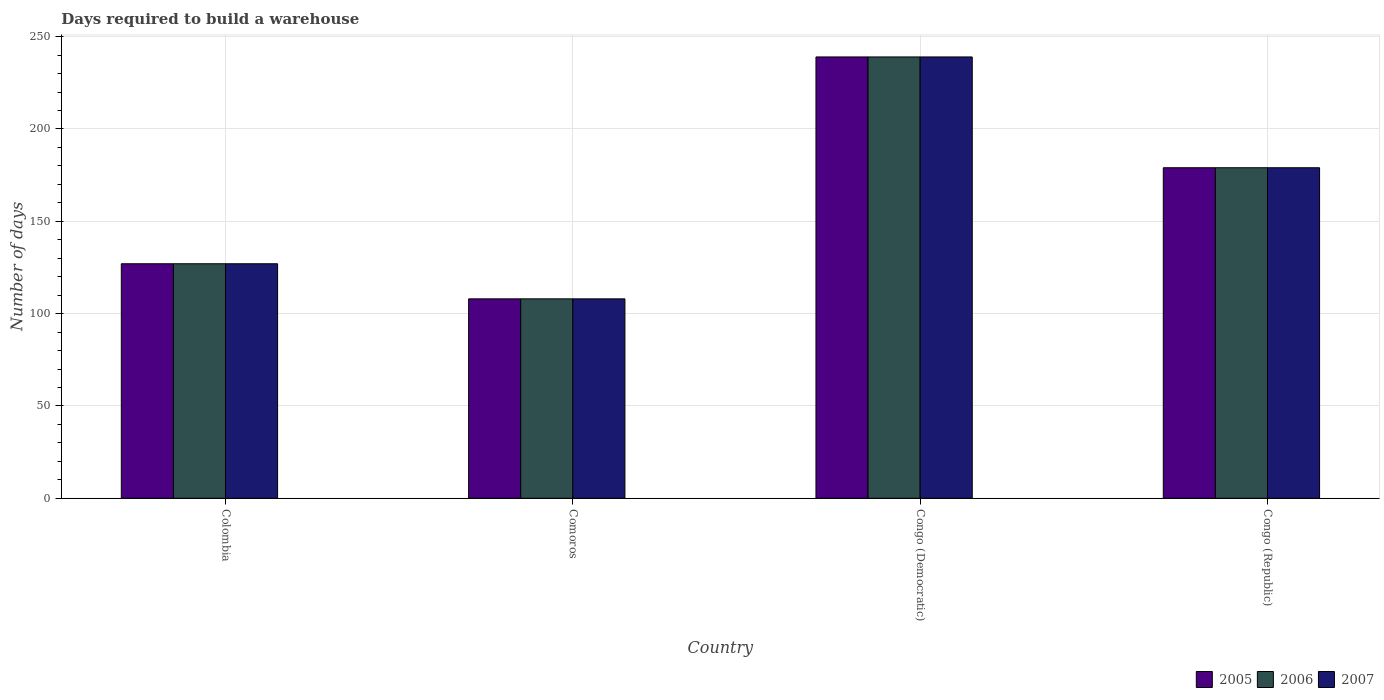Are the number of bars per tick equal to the number of legend labels?
Your answer should be very brief. Yes. How many bars are there on the 4th tick from the right?
Your response must be concise. 3. What is the label of the 4th group of bars from the left?
Keep it short and to the point. Congo (Republic). What is the days required to build a warehouse in in 2005 in Congo (Democratic)?
Offer a very short reply. 239. Across all countries, what is the maximum days required to build a warehouse in in 2007?
Keep it short and to the point. 239. Across all countries, what is the minimum days required to build a warehouse in in 2005?
Your answer should be very brief. 108. In which country was the days required to build a warehouse in in 2005 maximum?
Provide a succinct answer. Congo (Democratic). In which country was the days required to build a warehouse in in 2005 minimum?
Make the answer very short. Comoros. What is the total days required to build a warehouse in in 2007 in the graph?
Offer a very short reply. 653. What is the difference between the days required to build a warehouse in in 2005 in Colombia and that in Congo (Republic)?
Give a very brief answer. -52. What is the difference between the days required to build a warehouse in in 2006 in Comoros and the days required to build a warehouse in in 2007 in Colombia?
Your answer should be compact. -19. What is the average days required to build a warehouse in in 2007 per country?
Provide a succinct answer. 163.25. What is the ratio of the days required to build a warehouse in in 2007 in Congo (Democratic) to that in Congo (Republic)?
Keep it short and to the point. 1.34. Is the days required to build a warehouse in in 2005 in Comoros less than that in Congo (Republic)?
Make the answer very short. Yes. Is the difference between the days required to build a warehouse in in 2007 in Congo (Democratic) and Congo (Republic) greater than the difference between the days required to build a warehouse in in 2006 in Congo (Democratic) and Congo (Republic)?
Offer a terse response. No. What is the difference between the highest and the second highest days required to build a warehouse in in 2007?
Offer a terse response. 52. What is the difference between the highest and the lowest days required to build a warehouse in in 2006?
Offer a very short reply. 131. What does the 3rd bar from the right in Colombia represents?
Your response must be concise. 2005. Is it the case that in every country, the sum of the days required to build a warehouse in in 2005 and days required to build a warehouse in in 2007 is greater than the days required to build a warehouse in in 2006?
Your answer should be very brief. Yes. How many bars are there?
Offer a very short reply. 12. How many countries are there in the graph?
Keep it short and to the point. 4. How many legend labels are there?
Your answer should be very brief. 3. How are the legend labels stacked?
Keep it short and to the point. Horizontal. What is the title of the graph?
Offer a terse response. Days required to build a warehouse. What is the label or title of the Y-axis?
Your answer should be compact. Number of days. What is the Number of days of 2005 in Colombia?
Provide a short and direct response. 127. What is the Number of days of 2006 in Colombia?
Ensure brevity in your answer.  127. What is the Number of days in 2007 in Colombia?
Your response must be concise. 127. What is the Number of days of 2005 in Comoros?
Offer a very short reply. 108. What is the Number of days of 2006 in Comoros?
Ensure brevity in your answer.  108. What is the Number of days in 2007 in Comoros?
Keep it short and to the point. 108. What is the Number of days of 2005 in Congo (Democratic)?
Offer a very short reply. 239. What is the Number of days in 2006 in Congo (Democratic)?
Make the answer very short. 239. What is the Number of days of 2007 in Congo (Democratic)?
Your answer should be very brief. 239. What is the Number of days of 2005 in Congo (Republic)?
Give a very brief answer. 179. What is the Number of days in 2006 in Congo (Republic)?
Offer a very short reply. 179. What is the Number of days of 2007 in Congo (Republic)?
Your answer should be compact. 179. Across all countries, what is the maximum Number of days in 2005?
Offer a very short reply. 239. Across all countries, what is the maximum Number of days in 2006?
Your answer should be compact. 239. Across all countries, what is the maximum Number of days of 2007?
Your response must be concise. 239. Across all countries, what is the minimum Number of days in 2005?
Offer a terse response. 108. Across all countries, what is the minimum Number of days in 2006?
Your response must be concise. 108. Across all countries, what is the minimum Number of days of 2007?
Your response must be concise. 108. What is the total Number of days of 2005 in the graph?
Offer a very short reply. 653. What is the total Number of days in 2006 in the graph?
Offer a very short reply. 653. What is the total Number of days of 2007 in the graph?
Keep it short and to the point. 653. What is the difference between the Number of days of 2005 in Colombia and that in Comoros?
Make the answer very short. 19. What is the difference between the Number of days in 2005 in Colombia and that in Congo (Democratic)?
Make the answer very short. -112. What is the difference between the Number of days in 2006 in Colombia and that in Congo (Democratic)?
Your answer should be compact. -112. What is the difference between the Number of days in 2007 in Colombia and that in Congo (Democratic)?
Offer a terse response. -112. What is the difference between the Number of days of 2005 in Colombia and that in Congo (Republic)?
Your response must be concise. -52. What is the difference between the Number of days of 2006 in Colombia and that in Congo (Republic)?
Provide a short and direct response. -52. What is the difference between the Number of days in 2007 in Colombia and that in Congo (Republic)?
Provide a short and direct response. -52. What is the difference between the Number of days of 2005 in Comoros and that in Congo (Democratic)?
Keep it short and to the point. -131. What is the difference between the Number of days of 2006 in Comoros and that in Congo (Democratic)?
Offer a very short reply. -131. What is the difference between the Number of days of 2007 in Comoros and that in Congo (Democratic)?
Give a very brief answer. -131. What is the difference between the Number of days in 2005 in Comoros and that in Congo (Republic)?
Your response must be concise. -71. What is the difference between the Number of days of 2006 in Comoros and that in Congo (Republic)?
Provide a short and direct response. -71. What is the difference between the Number of days in 2007 in Comoros and that in Congo (Republic)?
Offer a terse response. -71. What is the difference between the Number of days in 2005 in Congo (Democratic) and that in Congo (Republic)?
Provide a short and direct response. 60. What is the difference between the Number of days of 2006 in Congo (Democratic) and that in Congo (Republic)?
Your response must be concise. 60. What is the difference between the Number of days in 2007 in Congo (Democratic) and that in Congo (Republic)?
Your answer should be very brief. 60. What is the difference between the Number of days of 2005 in Colombia and the Number of days of 2006 in Comoros?
Keep it short and to the point. 19. What is the difference between the Number of days of 2006 in Colombia and the Number of days of 2007 in Comoros?
Provide a succinct answer. 19. What is the difference between the Number of days of 2005 in Colombia and the Number of days of 2006 in Congo (Democratic)?
Ensure brevity in your answer.  -112. What is the difference between the Number of days in 2005 in Colombia and the Number of days in 2007 in Congo (Democratic)?
Offer a very short reply. -112. What is the difference between the Number of days in 2006 in Colombia and the Number of days in 2007 in Congo (Democratic)?
Offer a terse response. -112. What is the difference between the Number of days of 2005 in Colombia and the Number of days of 2006 in Congo (Republic)?
Provide a succinct answer. -52. What is the difference between the Number of days of 2005 in Colombia and the Number of days of 2007 in Congo (Republic)?
Your response must be concise. -52. What is the difference between the Number of days of 2006 in Colombia and the Number of days of 2007 in Congo (Republic)?
Provide a short and direct response. -52. What is the difference between the Number of days in 2005 in Comoros and the Number of days in 2006 in Congo (Democratic)?
Your response must be concise. -131. What is the difference between the Number of days of 2005 in Comoros and the Number of days of 2007 in Congo (Democratic)?
Your answer should be very brief. -131. What is the difference between the Number of days in 2006 in Comoros and the Number of days in 2007 in Congo (Democratic)?
Your response must be concise. -131. What is the difference between the Number of days in 2005 in Comoros and the Number of days in 2006 in Congo (Republic)?
Keep it short and to the point. -71. What is the difference between the Number of days of 2005 in Comoros and the Number of days of 2007 in Congo (Republic)?
Your answer should be very brief. -71. What is the difference between the Number of days of 2006 in Comoros and the Number of days of 2007 in Congo (Republic)?
Give a very brief answer. -71. What is the difference between the Number of days of 2005 in Congo (Democratic) and the Number of days of 2007 in Congo (Republic)?
Make the answer very short. 60. What is the average Number of days of 2005 per country?
Offer a very short reply. 163.25. What is the average Number of days of 2006 per country?
Provide a succinct answer. 163.25. What is the average Number of days of 2007 per country?
Your answer should be very brief. 163.25. What is the difference between the Number of days of 2005 and Number of days of 2007 in Colombia?
Your response must be concise. 0. What is the difference between the Number of days of 2006 and Number of days of 2007 in Colombia?
Offer a very short reply. 0. What is the difference between the Number of days in 2005 and Number of days in 2006 in Congo (Democratic)?
Your response must be concise. 0. What is the difference between the Number of days of 2005 and Number of days of 2007 in Congo (Democratic)?
Offer a very short reply. 0. What is the difference between the Number of days in 2005 and Number of days in 2006 in Congo (Republic)?
Make the answer very short. 0. What is the difference between the Number of days in 2005 and Number of days in 2007 in Congo (Republic)?
Provide a short and direct response. 0. What is the difference between the Number of days of 2006 and Number of days of 2007 in Congo (Republic)?
Ensure brevity in your answer.  0. What is the ratio of the Number of days of 2005 in Colombia to that in Comoros?
Give a very brief answer. 1.18. What is the ratio of the Number of days in 2006 in Colombia to that in Comoros?
Offer a terse response. 1.18. What is the ratio of the Number of days in 2007 in Colombia to that in Comoros?
Your answer should be very brief. 1.18. What is the ratio of the Number of days in 2005 in Colombia to that in Congo (Democratic)?
Your answer should be very brief. 0.53. What is the ratio of the Number of days of 2006 in Colombia to that in Congo (Democratic)?
Offer a very short reply. 0.53. What is the ratio of the Number of days of 2007 in Colombia to that in Congo (Democratic)?
Provide a succinct answer. 0.53. What is the ratio of the Number of days of 2005 in Colombia to that in Congo (Republic)?
Provide a short and direct response. 0.71. What is the ratio of the Number of days of 2006 in Colombia to that in Congo (Republic)?
Keep it short and to the point. 0.71. What is the ratio of the Number of days of 2007 in Colombia to that in Congo (Republic)?
Provide a short and direct response. 0.71. What is the ratio of the Number of days in 2005 in Comoros to that in Congo (Democratic)?
Ensure brevity in your answer.  0.45. What is the ratio of the Number of days of 2006 in Comoros to that in Congo (Democratic)?
Make the answer very short. 0.45. What is the ratio of the Number of days in 2007 in Comoros to that in Congo (Democratic)?
Keep it short and to the point. 0.45. What is the ratio of the Number of days in 2005 in Comoros to that in Congo (Republic)?
Your answer should be compact. 0.6. What is the ratio of the Number of days of 2006 in Comoros to that in Congo (Republic)?
Keep it short and to the point. 0.6. What is the ratio of the Number of days of 2007 in Comoros to that in Congo (Republic)?
Offer a very short reply. 0.6. What is the ratio of the Number of days of 2005 in Congo (Democratic) to that in Congo (Republic)?
Ensure brevity in your answer.  1.34. What is the ratio of the Number of days in 2006 in Congo (Democratic) to that in Congo (Republic)?
Offer a very short reply. 1.34. What is the ratio of the Number of days in 2007 in Congo (Democratic) to that in Congo (Republic)?
Your answer should be very brief. 1.34. What is the difference between the highest and the second highest Number of days of 2006?
Offer a terse response. 60. What is the difference between the highest and the second highest Number of days of 2007?
Your response must be concise. 60. What is the difference between the highest and the lowest Number of days of 2005?
Offer a very short reply. 131. What is the difference between the highest and the lowest Number of days of 2006?
Your response must be concise. 131. What is the difference between the highest and the lowest Number of days in 2007?
Your answer should be very brief. 131. 